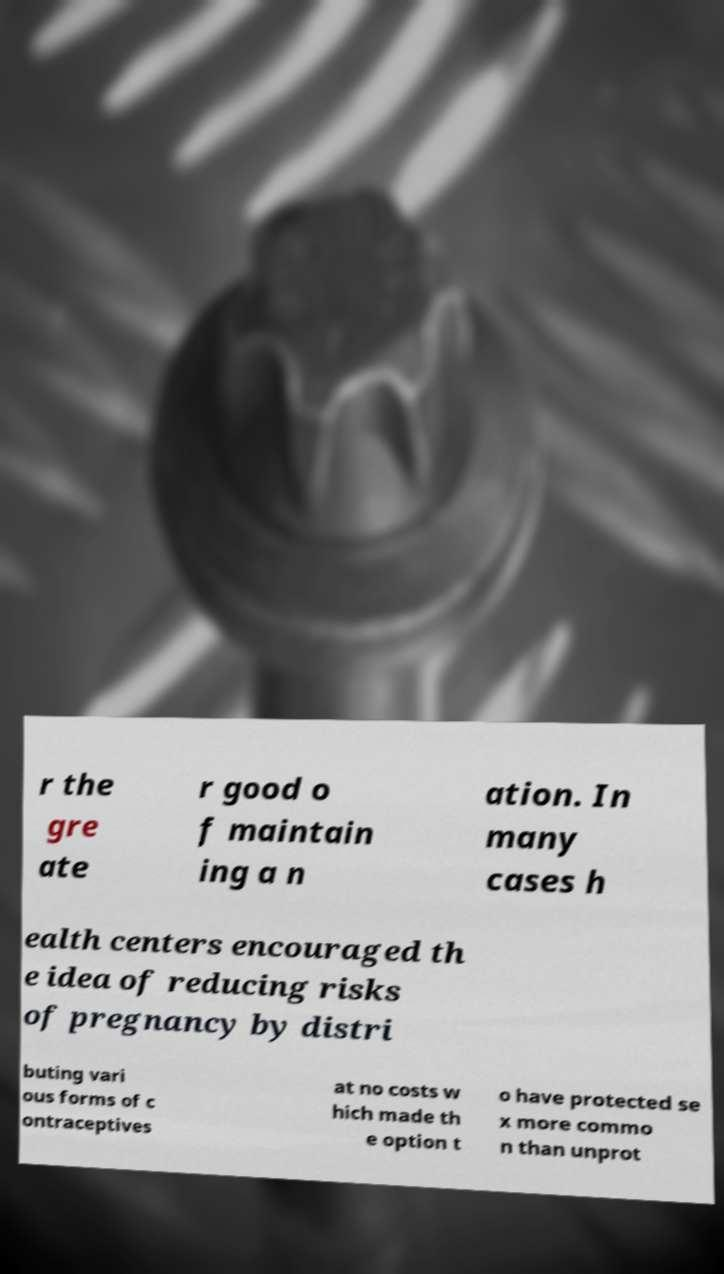Please identify and transcribe the text found in this image. r the gre ate r good o f maintain ing a n ation. In many cases h ealth centers encouraged th e idea of reducing risks of pregnancy by distri buting vari ous forms of c ontraceptives at no costs w hich made th e option t o have protected se x more commo n than unprot 